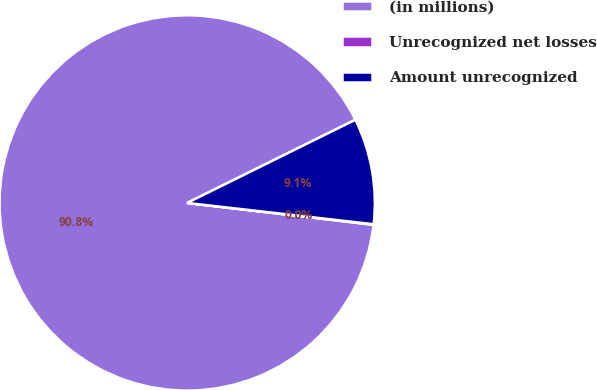Convert chart to OTSL. <chart><loc_0><loc_0><loc_500><loc_500><pie_chart><fcel>(in millions)<fcel>Unrecognized net losses<fcel>Amount unrecognized<nl><fcel>90.83%<fcel>0.05%<fcel>9.12%<nl></chart> 